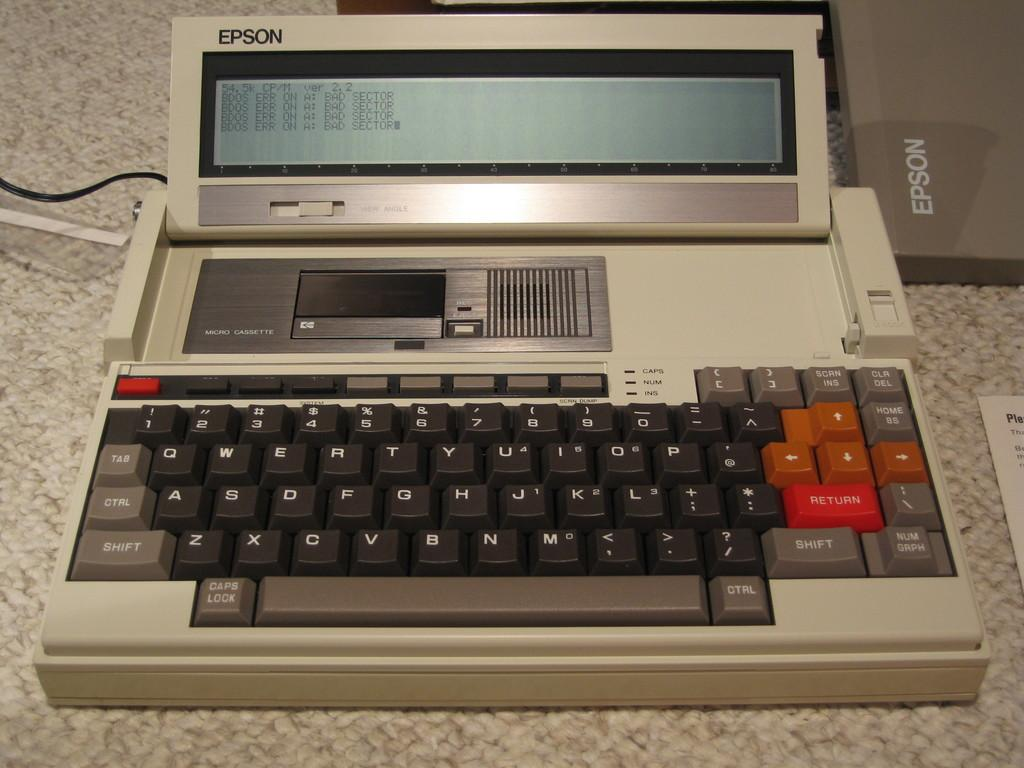Provide a one-sentence caption for the provided image. Many years ago, Epson used to manufacture computers. 